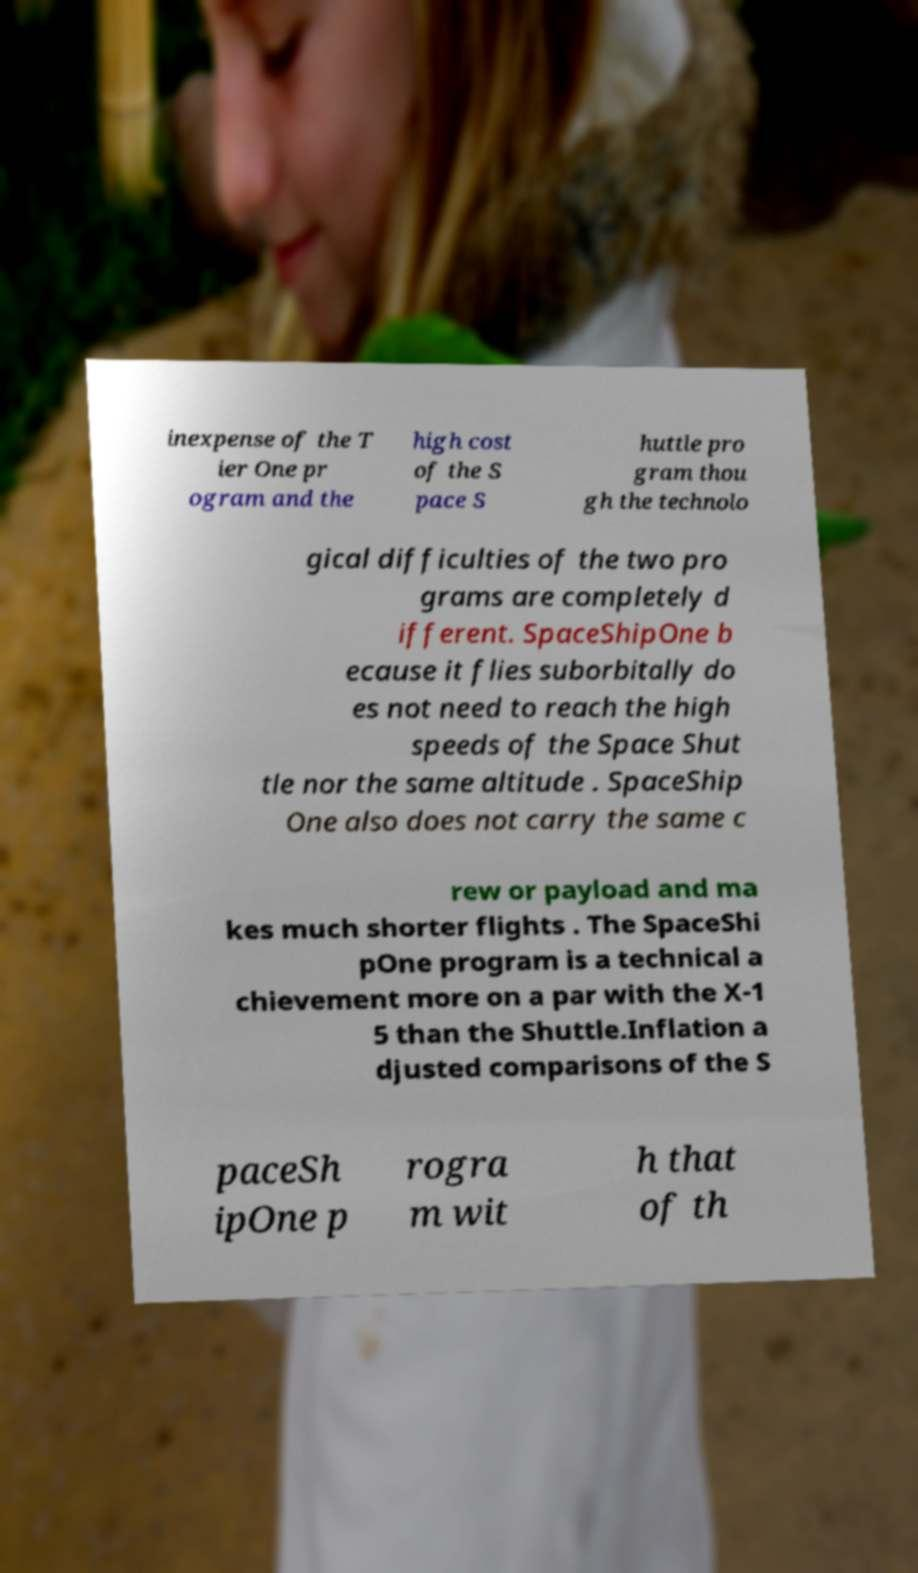There's text embedded in this image that I need extracted. Can you transcribe it verbatim? inexpense of the T ier One pr ogram and the high cost of the S pace S huttle pro gram thou gh the technolo gical difficulties of the two pro grams are completely d ifferent. SpaceShipOne b ecause it flies suborbitally do es not need to reach the high speeds of the Space Shut tle nor the same altitude . SpaceShip One also does not carry the same c rew or payload and ma kes much shorter flights . The SpaceShi pOne program is a technical a chievement more on a par with the X-1 5 than the Shuttle.Inflation a djusted comparisons of the S paceSh ipOne p rogra m wit h that of th 